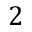<formula> <loc_0><loc_0><loc_500><loc_500>2</formula> 